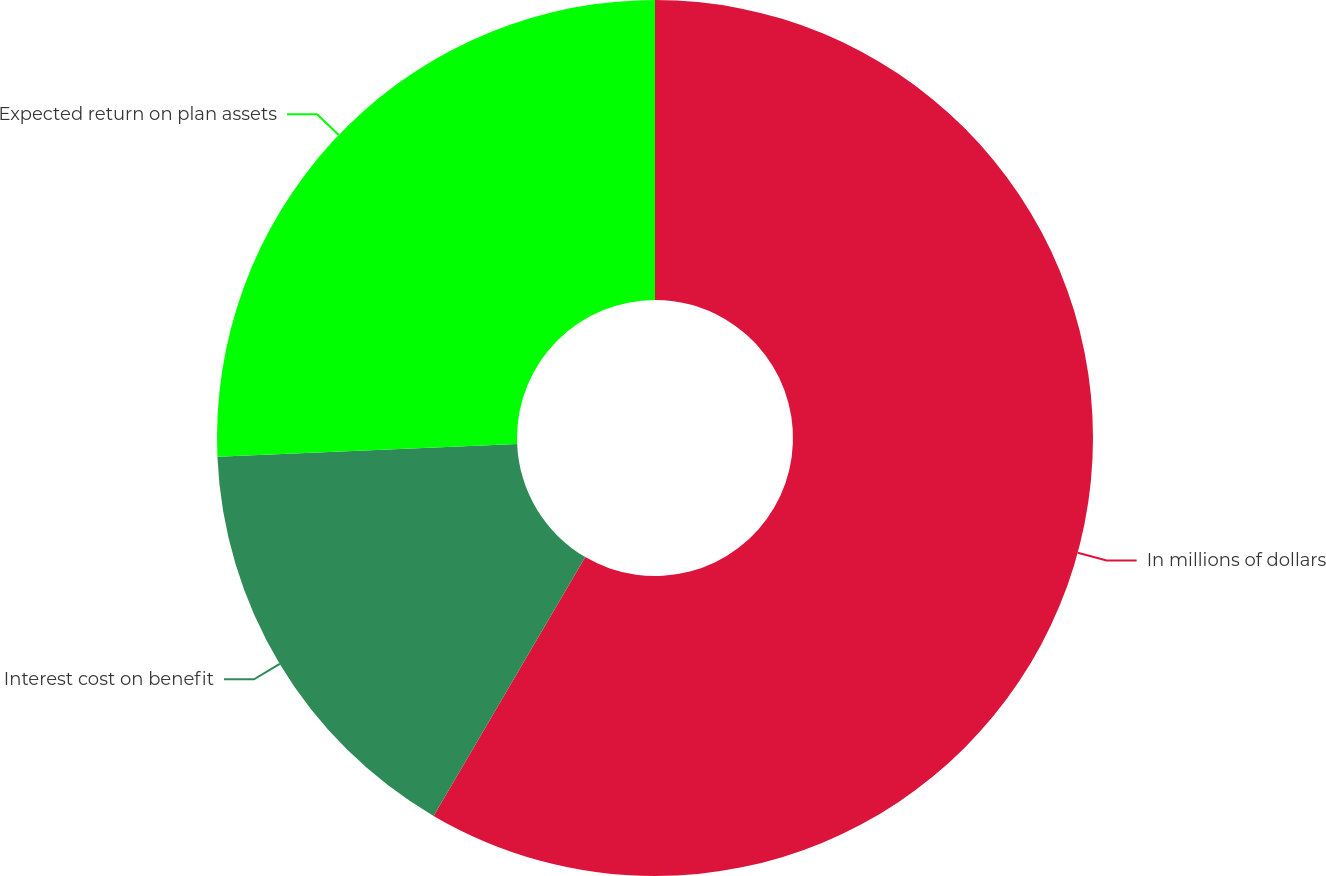<chart> <loc_0><loc_0><loc_500><loc_500><pie_chart><fcel>In millions of dollars<fcel>Interest cost on benefit<fcel>Expected return on plan assets<nl><fcel>58.43%<fcel>15.88%<fcel>25.68%<nl></chart> 